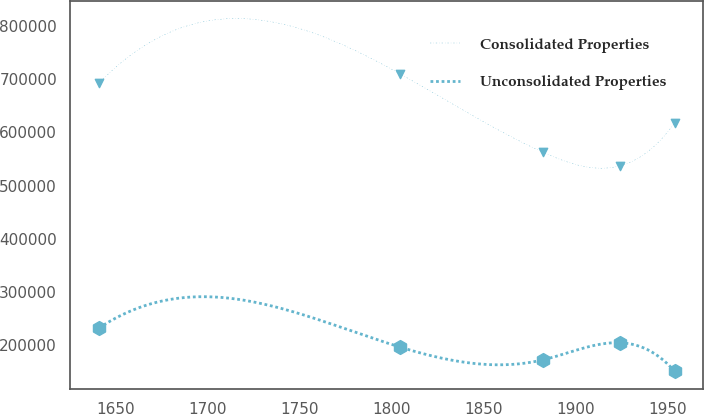Convert chart. <chart><loc_0><loc_0><loc_500><loc_500><line_chart><ecel><fcel>Consolidated Properties<fcel>Unconsolidated Properties<nl><fcel>1641.08<fcel>692619<fcel>232365<nl><fcel>1804.6<fcel>709835<fcel>196385<nl><fcel>1882.15<fcel>562641<fcel>172318<nl><fcel>1923.84<fcel>536784<fcel>204539<nl><fcel>1953.79<fcel>617881<fcel>150826<nl></chart> 